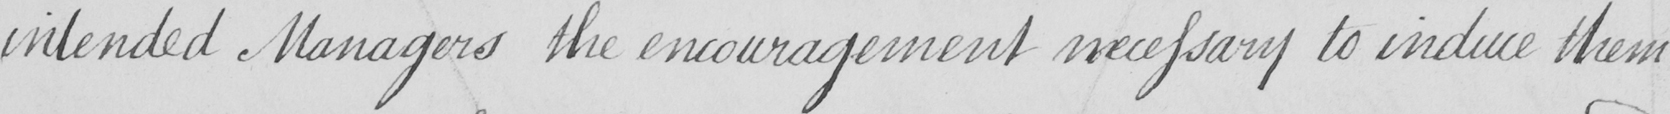Please transcribe the handwritten text in this image. intended Managers the encouragements necessary to induce them 